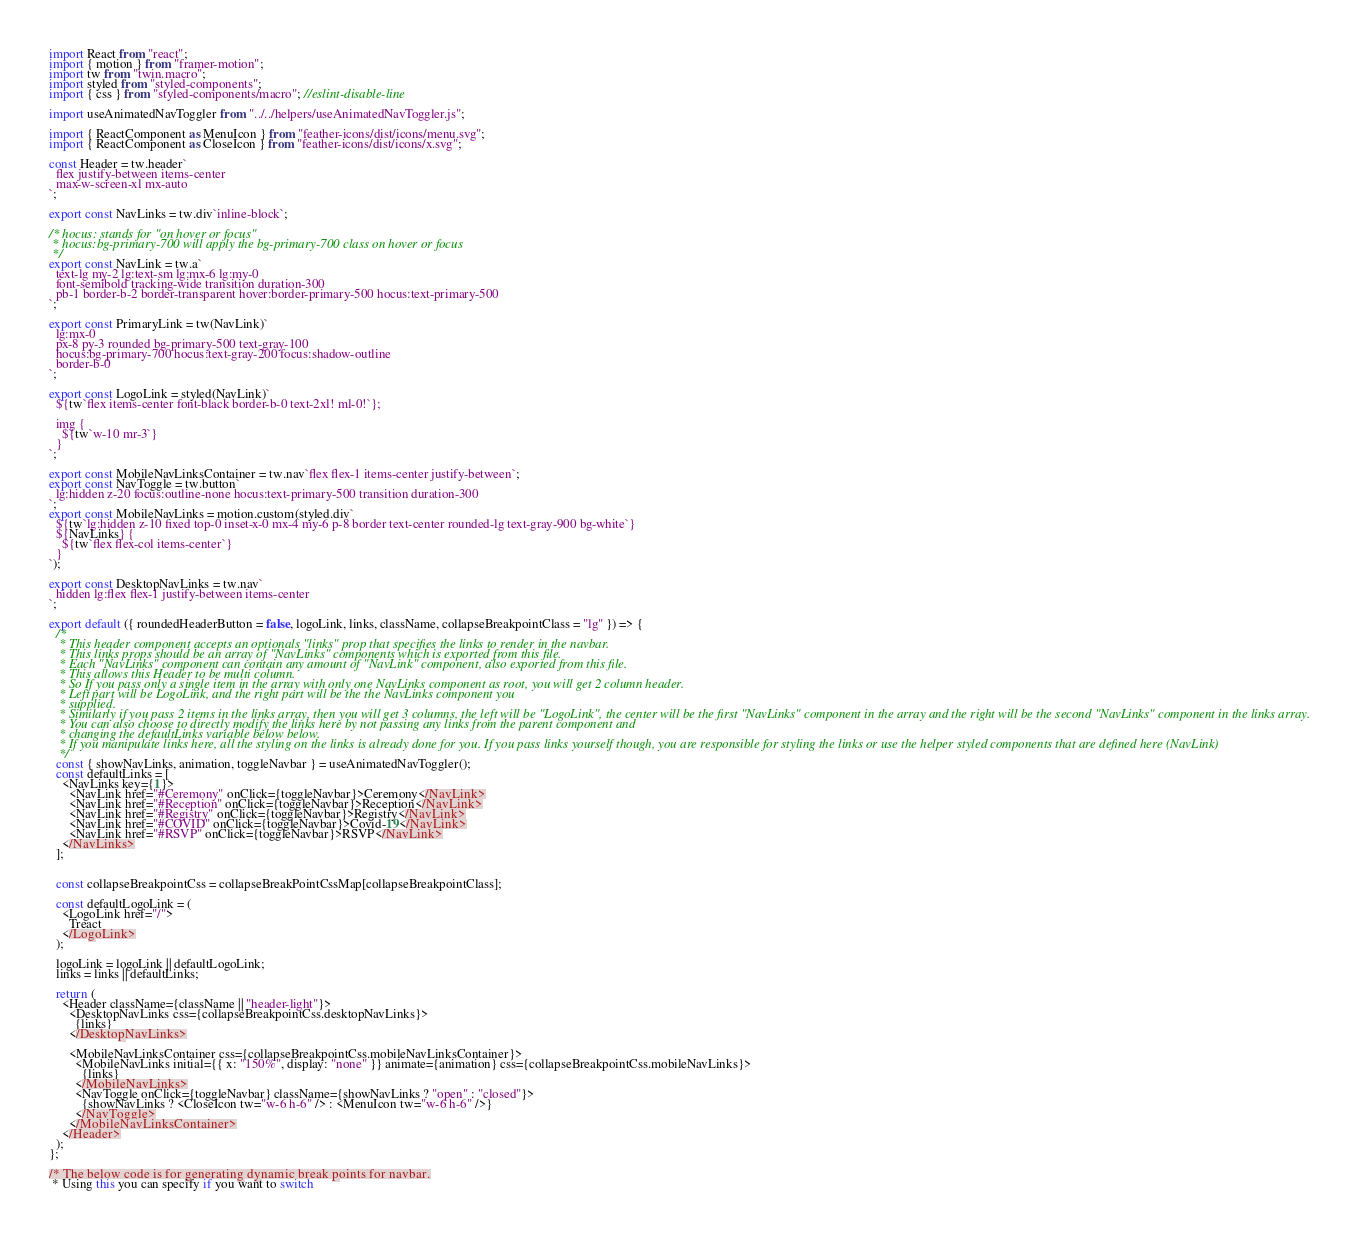<code> <loc_0><loc_0><loc_500><loc_500><_JavaScript_>import React from "react";
import { motion } from "framer-motion";
import tw from "twin.macro";
import styled from "styled-components";
import { css } from "styled-components/macro"; //eslint-disable-line

import useAnimatedNavToggler from "../../helpers/useAnimatedNavToggler.js";

import { ReactComponent as MenuIcon } from "feather-icons/dist/icons/menu.svg";
import { ReactComponent as CloseIcon } from "feather-icons/dist/icons/x.svg";

const Header = tw.header`
  flex justify-between items-center
  max-w-screen-xl mx-auto
`;

export const NavLinks = tw.div`inline-block`;

/* hocus: stands for "on hover or focus"
 * hocus:bg-primary-700 will apply the bg-primary-700 class on hover or focus
 */
export const NavLink = tw.a`
  text-lg my-2 lg:text-sm lg:mx-6 lg:my-0
  font-semibold tracking-wide transition duration-300
  pb-1 border-b-2 border-transparent hover:border-primary-500 hocus:text-primary-500
`;

export const PrimaryLink = tw(NavLink)`
  lg:mx-0
  px-8 py-3 rounded bg-primary-500 text-gray-100
  hocus:bg-primary-700 hocus:text-gray-200 focus:shadow-outline
  border-b-0
`;

export const LogoLink = styled(NavLink)`
  ${tw`flex items-center font-black border-b-0 text-2xl! ml-0!`};

  img {
    ${tw`w-10 mr-3`}
  }
`;

export const MobileNavLinksContainer = tw.nav`flex flex-1 items-center justify-between`;
export const NavToggle = tw.button`
  lg:hidden z-20 focus:outline-none hocus:text-primary-500 transition duration-300
`;
export const MobileNavLinks = motion.custom(styled.div`
  ${tw`lg:hidden z-10 fixed top-0 inset-x-0 mx-4 my-6 p-8 border text-center rounded-lg text-gray-900 bg-white`}
  ${NavLinks} {
    ${tw`flex flex-col items-center`}
  }
`);

export const DesktopNavLinks = tw.nav`
  hidden lg:flex flex-1 justify-between items-center
`;

export default ({ roundedHeaderButton = false, logoLink, links, className, collapseBreakpointClass = "lg" }) => {
  /*
   * This header component accepts an optionals "links" prop that specifies the links to render in the navbar.
   * This links props should be an array of "NavLinks" components which is exported from this file.
   * Each "NavLinks" component can contain any amount of "NavLink" component, also exported from this file.
   * This allows this Header to be multi column.
   * So If you pass only a single item in the array with only one NavLinks component as root, you will get 2 column header.
   * Left part will be LogoLink, and the right part will be the the NavLinks component you
   * supplied.
   * Similarly if you pass 2 items in the links array, then you will get 3 columns, the left will be "LogoLink", the center will be the first "NavLinks" component in the array and the right will be the second "NavLinks" component in the links array.
   * You can also choose to directly modify the links here by not passing any links from the parent component and
   * changing the defaultLinks variable below below.
   * If you manipulate links here, all the styling on the links is already done for you. If you pass links yourself though, you are responsible for styling the links or use the helper styled components that are defined here (NavLink)
   */
  const { showNavLinks, animation, toggleNavbar } = useAnimatedNavToggler();
  const defaultLinks = [
    <NavLinks key={1}>
      <NavLink href="#Ceremony" onClick={toggleNavbar}>Ceremony</NavLink>
      <NavLink href="#Reception" onClick={toggleNavbar}>Reception</NavLink>
      <NavLink href="#Registry" onClick={toggleNavbar}>Registry</NavLink>
      <NavLink href="#COVID" onClick={toggleNavbar}>Covid-19</NavLink>
      <NavLink href="#RSVP" onClick={toggleNavbar}>RSVP</NavLink>
    </NavLinks>
  ];

  
  const collapseBreakpointCss = collapseBreakPointCssMap[collapseBreakpointClass];

  const defaultLogoLink = (
    <LogoLink href="/">
      Treact
    </LogoLink>
  );

  logoLink = logoLink || defaultLogoLink;
  links = links || defaultLinks;

  return (
    <Header className={className || "header-light"}>
      <DesktopNavLinks css={collapseBreakpointCss.desktopNavLinks}>
        {links}
      </DesktopNavLinks>

      <MobileNavLinksContainer css={collapseBreakpointCss.mobileNavLinksContainer}>
        <MobileNavLinks initial={{ x: "150%", display: "none" }} animate={animation} css={collapseBreakpointCss.mobileNavLinks}>
          {links}
        </MobileNavLinks>
        <NavToggle onClick={toggleNavbar} className={showNavLinks ? "open" : "closed"}>
          {showNavLinks ? <CloseIcon tw="w-6 h-6" /> : <MenuIcon tw="w-6 h-6" />}
        </NavToggle>
      </MobileNavLinksContainer>
    </Header>
  );
};

/* The below code is for generating dynamic break points for navbar.
 * Using this you can specify if you want to switch</code> 